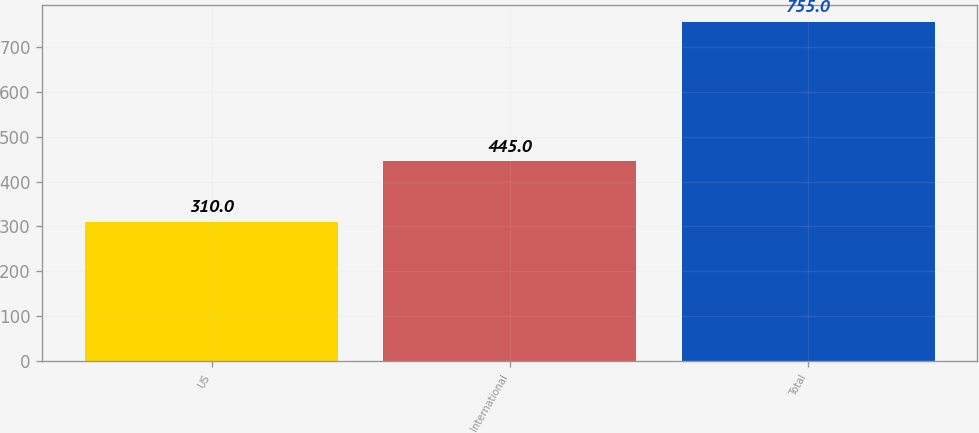<chart> <loc_0><loc_0><loc_500><loc_500><bar_chart><fcel>US<fcel>International<fcel>Total<nl><fcel>310<fcel>445<fcel>755<nl></chart> 